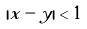Convert formula to latex. <formula><loc_0><loc_0><loc_500><loc_500>| x - y | < 1</formula> 